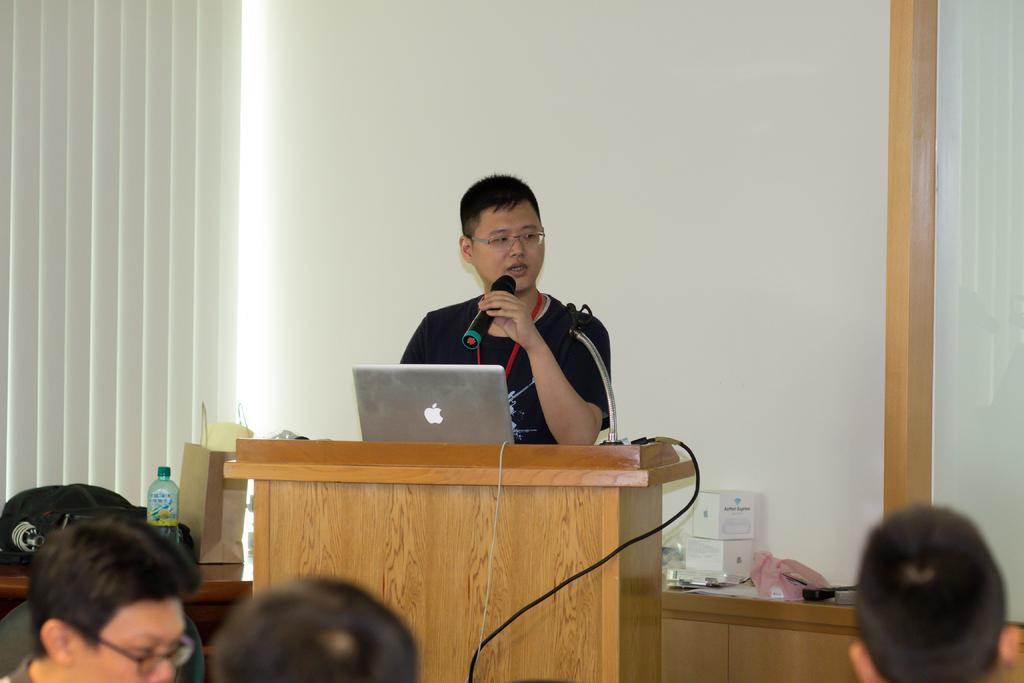Could you give a brief overview of what you see in this image? In this picture we can see there are heads of three persons. In front of the persons there is a podium. On the podium there is a cable, laptop and a stand. A man is standing behind the podium and he is holding a microphone. On the left side of the man there is a table and on the table there is a bottle, paper bag and black bag. Behind the man there are some objects, wall and window shutters. 